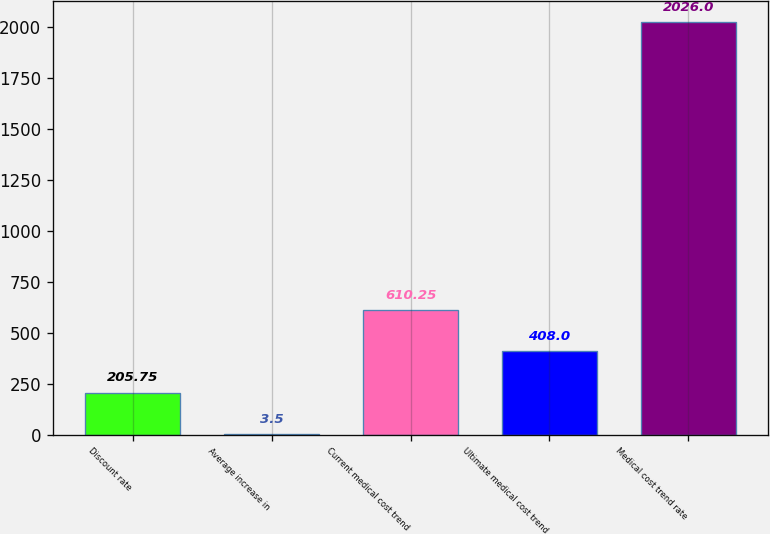Convert chart to OTSL. <chart><loc_0><loc_0><loc_500><loc_500><bar_chart><fcel>Discount rate<fcel>Average increase in<fcel>Current medical cost trend<fcel>Ultimate medical cost trend<fcel>Medical cost trend rate<nl><fcel>205.75<fcel>3.5<fcel>610.25<fcel>408<fcel>2026<nl></chart> 